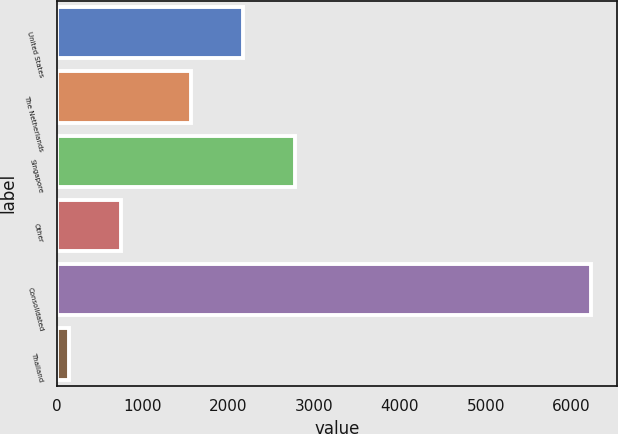<chart> <loc_0><loc_0><loc_500><loc_500><bar_chart><fcel>United States<fcel>The Netherlands<fcel>Singapore<fcel>Other<fcel>Consolidated<fcel>Thailand<nl><fcel>2166.2<fcel>1558<fcel>2774.4<fcel>750.2<fcel>6224<fcel>142<nl></chart> 